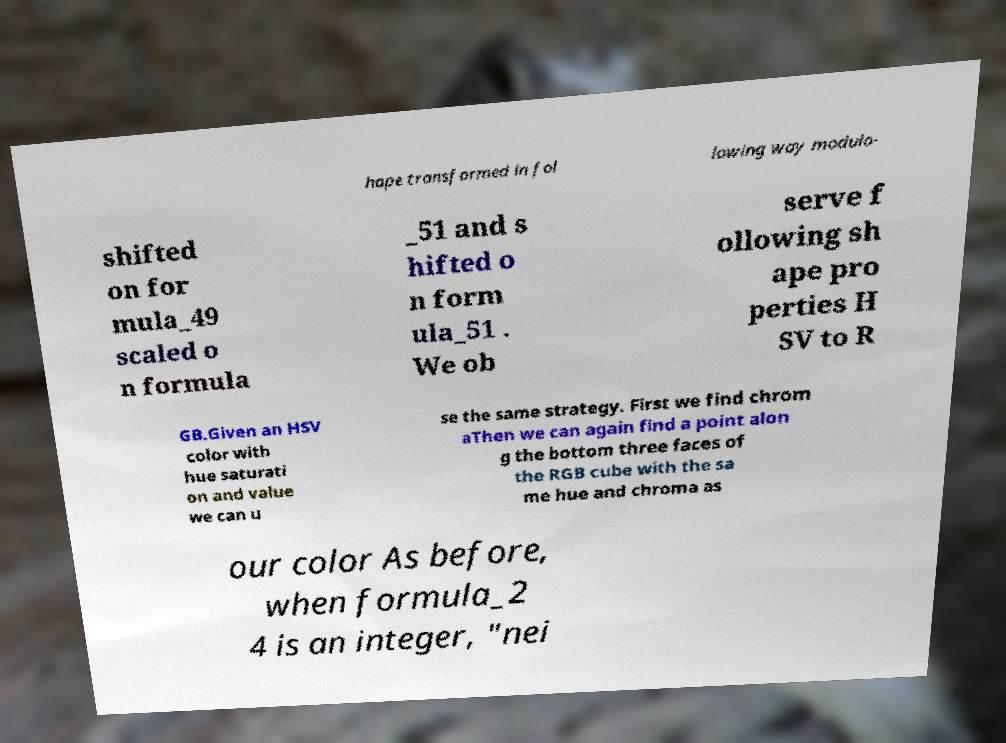Can you read and provide the text displayed in the image?This photo seems to have some interesting text. Can you extract and type it out for me? hape transformed in fol lowing way modulo- shifted on for mula_49 scaled o n formula _51 and s hifted o n form ula_51 . We ob serve f ollowing sh ape pro perties H SV to R GB.Given an HSV color with hue saturati on and value we can u se the same strategy. First we find chrom aThen we can again find a point alon g the bottom three faces of the RGB cube with the sa me hue and chroma as our color As before, when formula_2 4 is an integer, "nei 